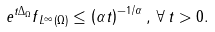<formula> <loc_0><loc_0><loc_500><loc_500>\| e ^ { t \Delta _ { \Omega } } f \| _ { L ^ { \infty } ( \Omega ) } \leq \left ( \alpha t \right ) ^ { - 1 / \alpha } , \, \forall \, t > 0 .</formula> 